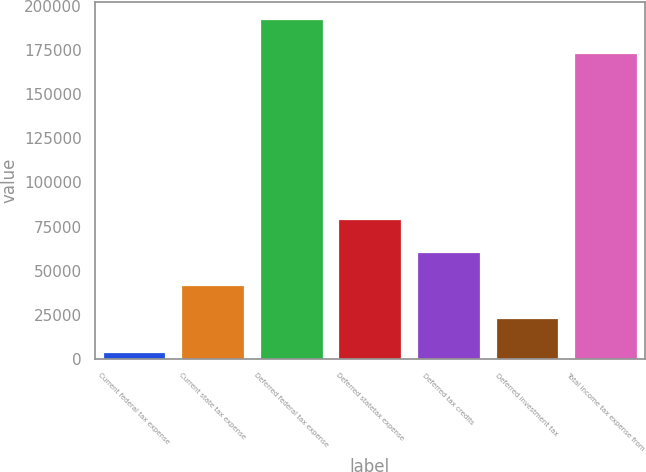<chart> <loc_0><loc_0><loc_500><loc_500><bar_chart><fcel>Current federal tax expense<fcel>Current state tax expense<fcel>Deferred federal tax expense<fcel>Deferred statetax expense<fcel>Deferred tax credits<fcel>Deferred investment tax<fcel>Total income tax expense from<nl><fcel>4122<fcel>41677.6<fcel>192317<fcel>79233.2<fcel>60455.4<fcel>22899.8<fcel>173539<nl></chart> 